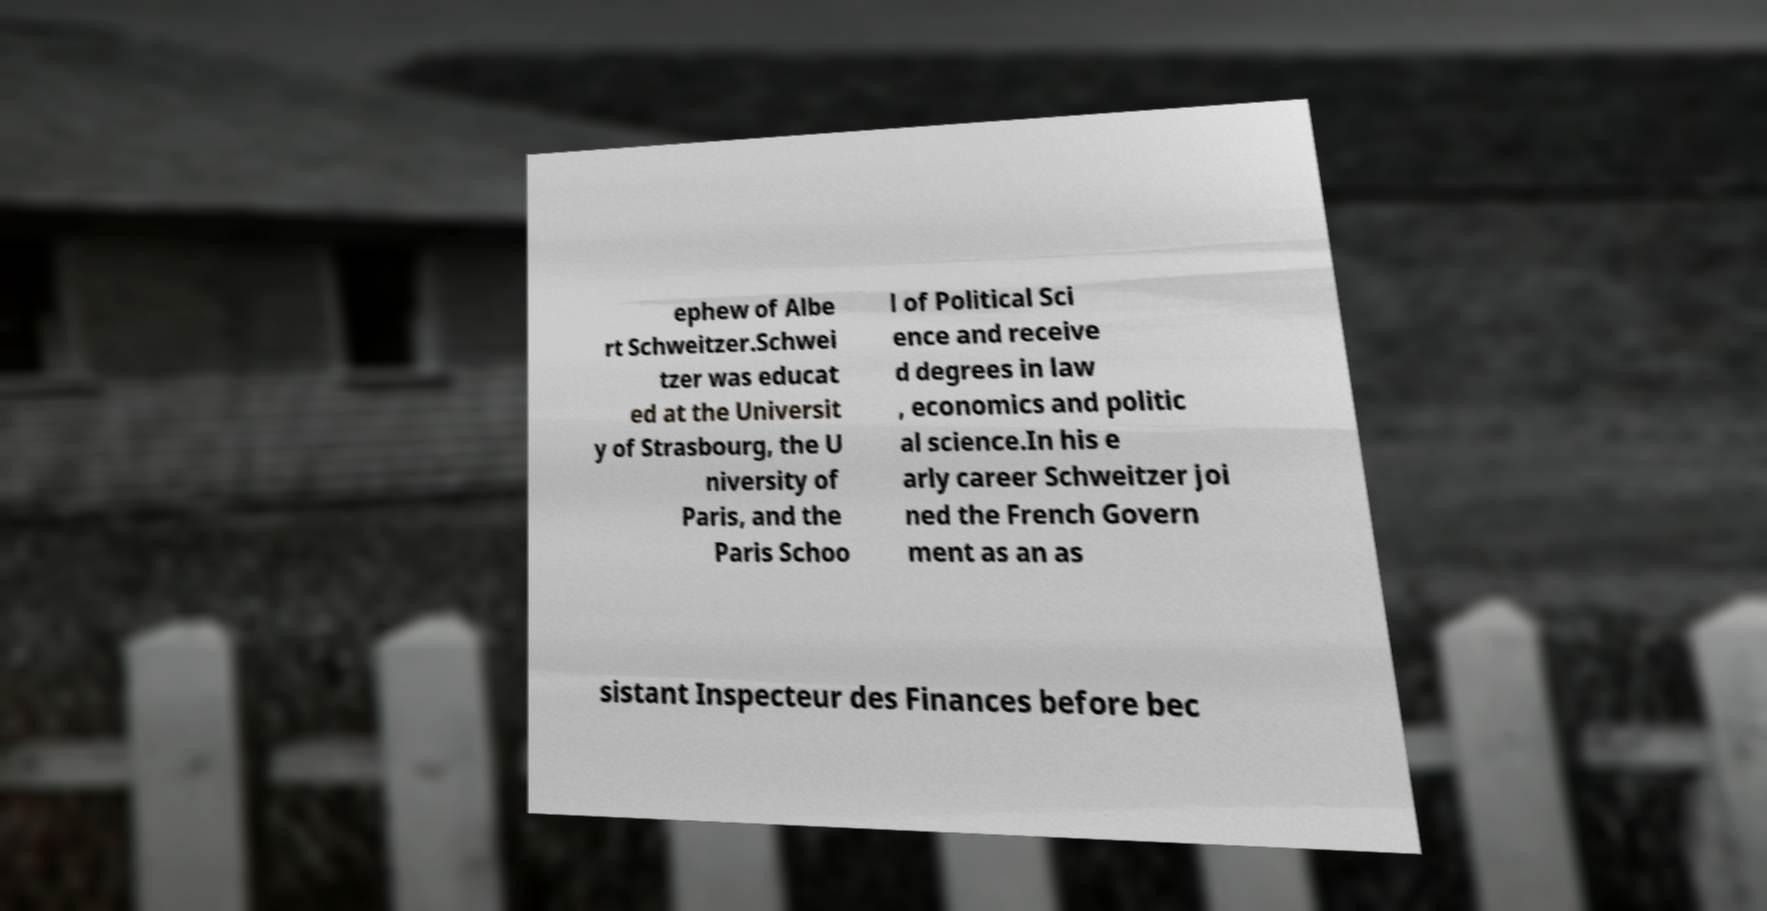Could you extract and type out the text from this image? ephew of Albe rt Schweitzer.Schwei tzer was educat ed at the Universit y of Strasbourg, the U niversity of Paris, and the Paris Schoo l of Political Sci ence and receive d degrees in law , economics and politic al science.In his e arly career Schweitzer joi ned the French Govern ment as an as sistant Inspecteur des Finances before bec 